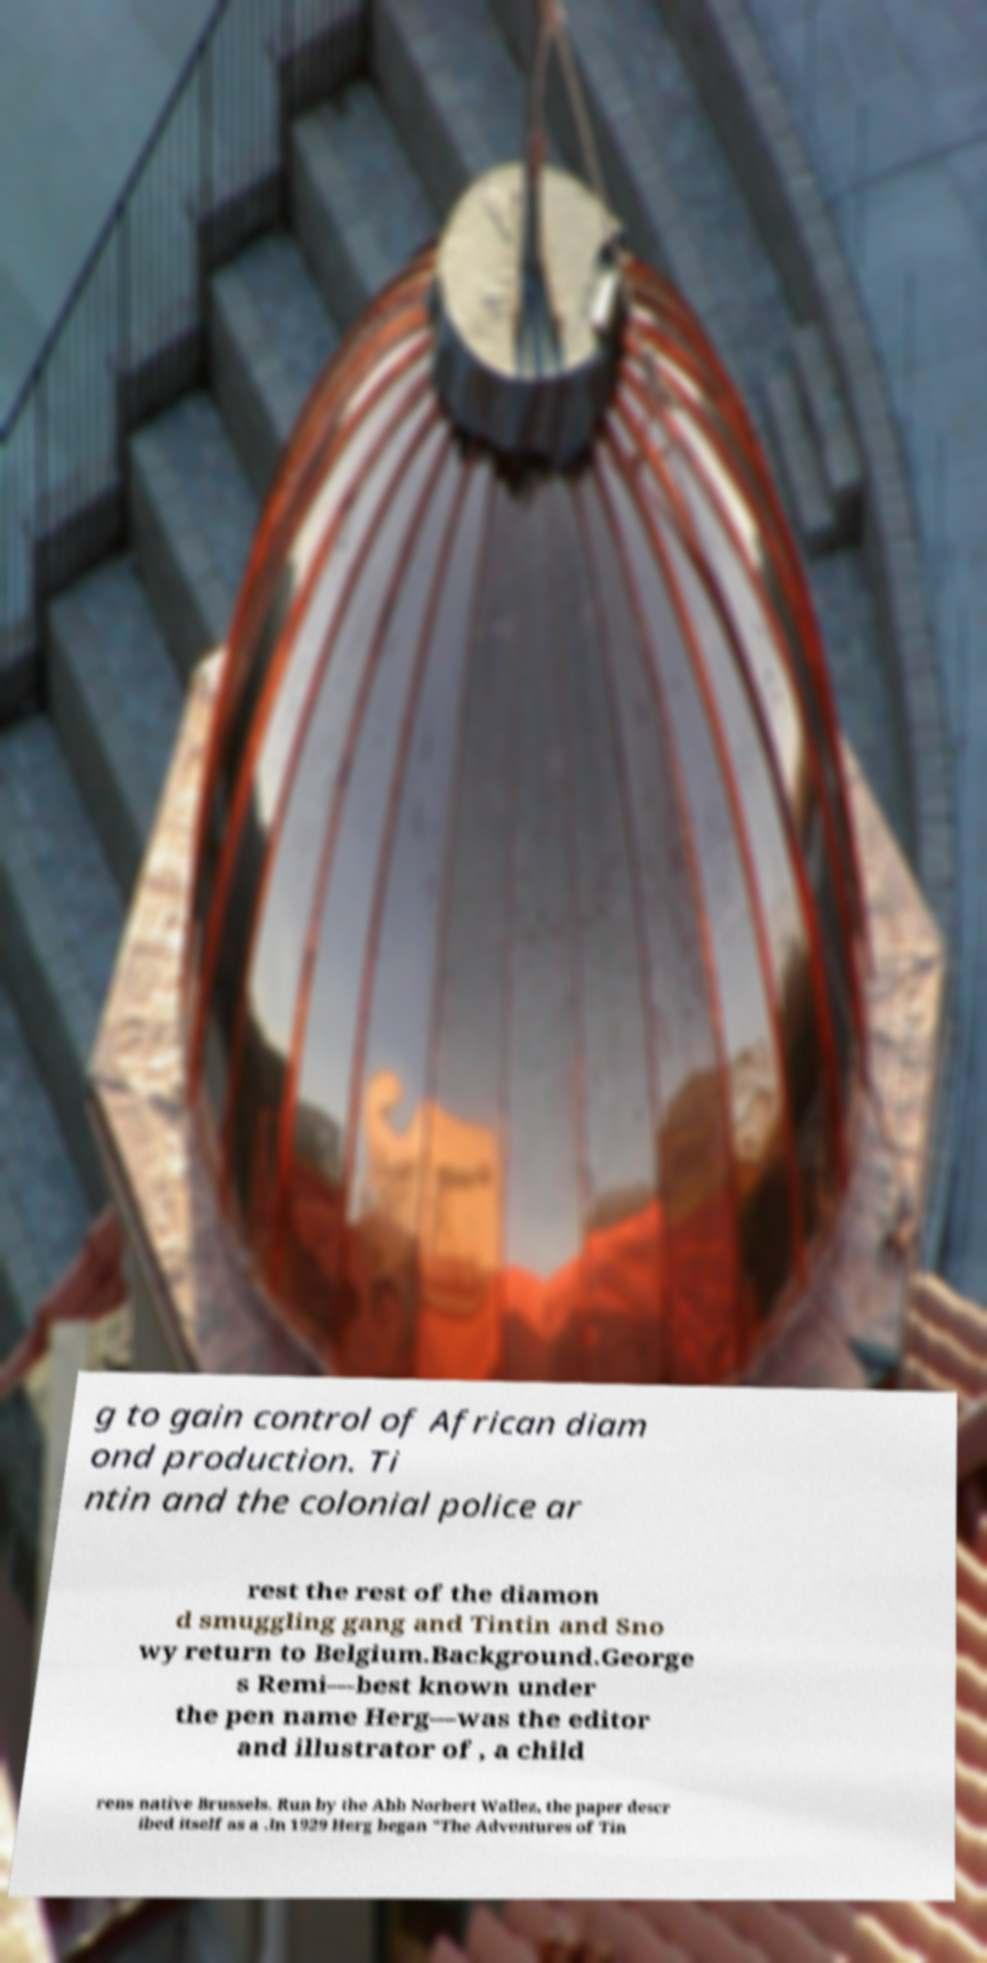Can you read and provide the text displayed in the image?This photo seems to have some interesting text. Can you extract and type it out for me? g to gain control of African diam ond production. Ti ntin and the colonial police ar rest the rest of the diamon d smuggling gang and Tintin and Sno wy return to Belgium.Background.George s Remi—best known under the pen name Herg—was the editor and illustrator of , a child rens native Brussels. Run by the Abb Norbert Wallez, the paper descr ibed itself as a .In 1929 Herg began "The Adventures of Tin 